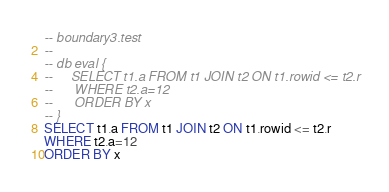<code> <loc_0><loc_0><loc_500><loc_500><_SQL_>-- boundary3.test
-- 
-- db eval {
--     SELECT t1.a FROM t1 JOIN t2 ON t1.rowid <= t2.r
--      WHERE t2.a=12
--      ORDER BY x
-- }
SELECT t1.a FROM t1 JOIN t2 ON t1.rowid <= t2.r
WHERE t2.a=12
ORDER BY x</code> 